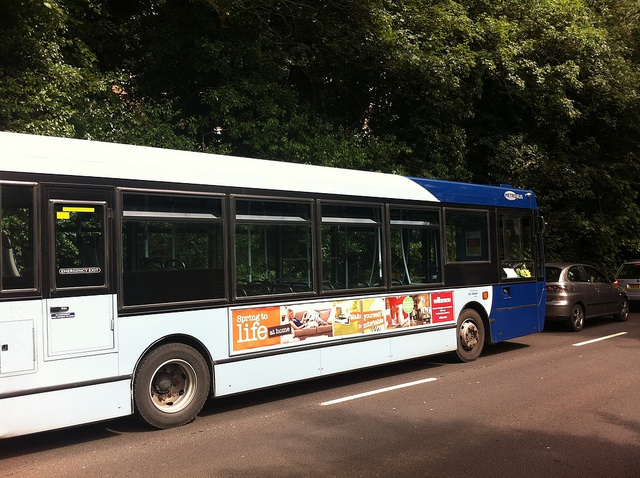Describe the objects in this image and their specific colors. I can see bus in black, white, gray, and navy tones, car in black, gray, and maroon tones, and car in black and gray tones in this image. 